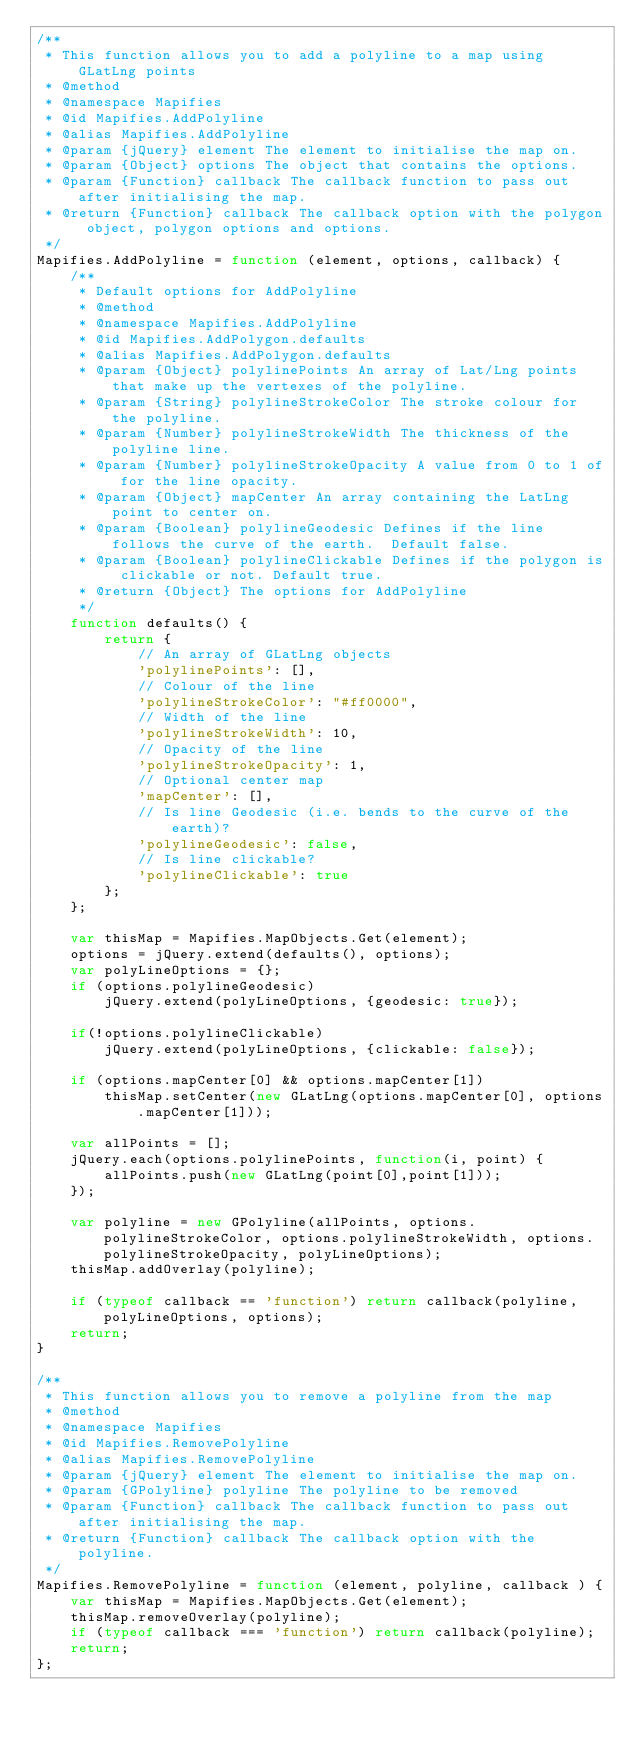<code> <loc_0><loc_0><loc_500><loc_500><_JavaScript_>/**
 * This function allows you to add a polyline to a map using GLatLng points
 * @method
 * @namespace Mapifies
 * @id Mapifies.AddPolyline
 * @alias Mapifies.AddPolyline
 * @param {jQuery} element The element to initialise the map on.
 * @param {Object} options The object that contains the options.
 * @param {Function} callback The callback function to pass out after initialising the map.
 * @return {Function} callback The callback option with the polygon object, polygon options and options.
 */
Mapifies.AddPolyline = function (element, options, callback) {
	/**
	 * Default options for AddPolyline
	 * @method
	 * @namespace Mapifies.AddPolyline
	 * @id Mapifies.AddPolygon.defaults
	 * @alias Mapifies.AddPolygon.defaults
	 * @param {Object} polylinePoints An array of Lat/Lng points that make up the vertexes of the polyline.
	 * @param {String} polylineStrokeColor The stroke colour for the polyline.
	 * @param {Number} polylineStrokeWidth The thickness of the polyline line.
	 * @param {Number} polylineStrokeOpacity A value from 0 to 1 of for the line opacity.
	 * @param {Object} mapCenter An array containing the LatLng point to center on.
	 * @param {Boolean} polylineGeodesic Defines if the line follows the curve of the earth.  Default false.
	 * @param {Boolean} polylineClickable Defines if the polygon is clickable or not. Default true.
	 * @return {Object} The options for AddPolyline
	 */
	function defaults() {
		return {
			// An array of GLatLng objects
			'polylinePoints': [],
			// Colour of the line
			'polylineStrokeColor': "#ff0000",
			// Width of the line
			'polylineStrokeWidth': 10,
			// Opacity of the line
			'polylineStrokeOpacity': 1,
			// Optional center map
			'mapCenter': [],
			// Is line Geodesic (i.e. bends to the curve of the earth)?
			'polylineGeodesic': false,
			// Is line clickable?
			'polylineClickable': true
		};
	};
	
	var thisMap = Mapifies.MapObjects.Get(element);
	options = jQuery.extend(defaults(), options);
	var polyLineOptions = {};
	if (options.polylineGeodesic)
		jQuery.extend(polyLineOptions, {geodesic: true});
			
	if(!options.polylineClickable)
		jQuery.extend(polyLineOptions, {clickable: false});

	if (options.mapCenter[0] && options.mapCenter[1])
		thisMap.setCenter(new GLatLng(options.mapCenter[0], options.mapCenter[1]));

	var allPoints = [];
	jQuery.each(options.polylinePoints, function(i, point) {
		allPoints.push(new GLatLng(point[0],point[1]));
	});

	var polyline = new GPolyline(allPoints, options.polylineStrokeColor, options.polylineStrokeWidth, options.polylineStrokeOpacity, polyLineOptions);
	thisMap.addOverlay(polyline);
		
	if (typeof callback == 'function') return callback(polyline, polyLineOptions, options);
	return;
}

/**
 * This function allows you to remove a polyline from the map
 * @method
 * @namespace Mapifies
 * @id Mapifies.RemovePolyline
 * @alias Mapifies.RemovePolyline
 * @param {jQuery} element The element to initialise the map on.
 * @param {GPolyline} polyline The polyline to be removed
 * @param {Function} callback The callback function to pass out after initialising the map.
 * @return {Function} callback The callback option with the polyline.
 */
Mapifies.RemovePolyline = function (element, polyline, callback ) {
	var thisMap = Mapifies.MapObjects.Get(element);
	thisMap.removeOverlay(polyline);
	if (typeof callback === 'function') return callback(polyline);
	return;
};
</code> 